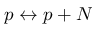<formula> <loc_0><loc_0><loc_500><loc_500>p \leftrightarrow p + N</formula> 